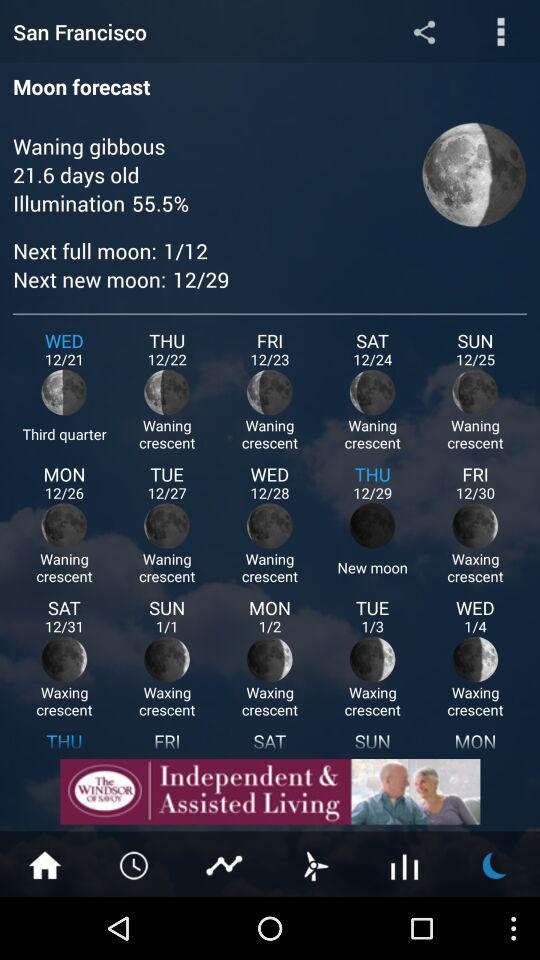What is the date of the next new moon? The date of the next new moon is December 29. 